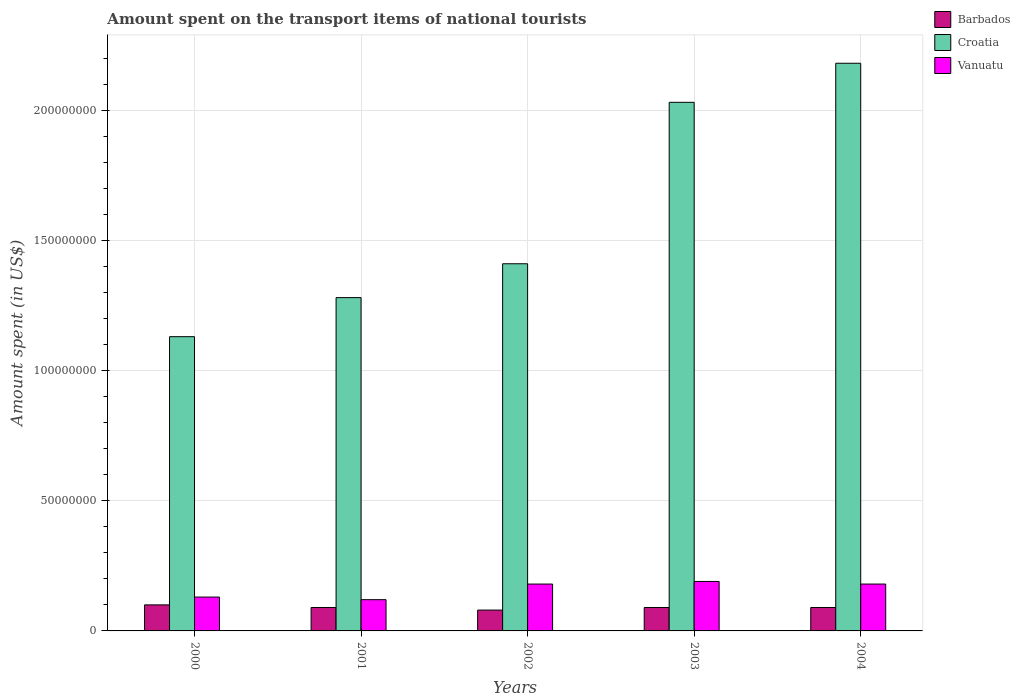How many different coloured bars are there?
Keep it short and to the point. 3. How many groups of bars are there?
Your answer should be compact. 5. Are the number of bars on each tick of the X-axis equal?
Your answer should be very brief. Yes. How many bars are there on the 4th tick from the left?
Provide a short and direct response. 3. What is the label of the 1st group of bars from the left?
Provide a short and direct response. 2000. In how many cases, is the number of bars for a given year not equal to the number of legend labels?
Give a very brief answer. 0. What is the amount spent on the transport items of national tourists in Barbados in 2000?
Provide a succinct answer. 1.00e+07. Across all years, what is the minimum amount spent on the transport items of national tourists in Vanuatu?
Make the answer very short. 1.20e+07. What is the total amount spent on the transport items of national tourists in Vanuatu in the graph?
Offer a terse response. 8.00e+07. What is the difference between the amount spent on the transport items of national tourists in Vanuatu in 2000 and that in 2002?
Offer a terse response. -5.00e+06. What is the difference between the amount spent on the transport items of national tourists in Vanuatu in 2000 and the amount spent on the transport items of national tourists in Croatia in 2001?
Your response must be concise. -1.15e+08. What is the average amount spent on the transport items of national tourists in Vanuatu per year?
Make the answer very short. 1.60e+07. In the year 2000, what is the difference between the amount spent on the transport items of national tourists in Vanuatu and amount spent on the transport items of national tourists in Croatia?
Ensure brevity in your answer.  -1.00e+08. In how many years, is the amount spent on the transport items of national tourists in Vanuatu greater than 140000000 US$?
Your answer should be very brief. 0. What is the ratio of the amount spent on the transport items of national tourists in Vanuatu in 2000 to that in 2001?
Offer a very short reply. 1.08. Is the amount spent on the transport items of national tourists in Croatia in 2003 less than that in 2004?
Keep it short and to the point. Yes. Is the difference between the amount spent on the transport items of national tourists in Vanuatu in 2001 and 2004 greater than the difference between the amount spent on the transport items of national tourists in Croatia in 2001 and 2004?
Offer a very short reply. Yes. In how many years, is the amount spent on the transport items of national tourists in Croatia greater than the average amount spent on the transport items of national tourists in Croatia taken over all years?
Your answer should be compact. 2. What does the 3rd bar from the left in 2004 represents?
Offer a terse response. Vanuatu. What does the 2nd bar from the right in 2000 represents?
Ensure brevity in your answer.  Croatia. Is it the case that in every year, the sum of the amount spent on the transport items of national tourists in Barbados and amount spent on the transport items of national tourists in Vanuatu is greater than the amount spent on the transport items of national tourists in Croatia?
Keep it short and to the point. No. How many years are there in the graph?
Keep it short and to the point. 5. Are the values on the major ticks of Y-axis written in scientific E-notation?
Provide a short and direct response. No. Does the graph contain any zero values?
Your response must be concise. No. Where does the legend appear in the graph?
Provide a succinct answer. Top right. What is the title of the graph?
Make the answer very short. Amount spent on the transport items of national tourists. Does "Namibia" appear as one of the legend labels in the graph?
Keep it short and to the point. No. What is the label or title of the Y-axis?
Ensure brevity in your answer.  Amount spent (in US$). What is the Amount spent (in US$) of Barbados in 2000?
Your response must be concise. 1.00e+07. What is the Amount spent (in US$) in Croatia in 2000?
Your answer should be compact. 1.13e+08. What is the Amount spent (in US$) in Vanuatu in 2000?
Give a very brief answer. 1.30e+07. What is the Amount spent (in US$) in Barbados in 2001?
Make the answer very short. 9.00e+06. What is the Amount spent (in US$) of Croatia in 2001?
Offer a terse response. 1.28e+08. What is the Amount spent (in US$) in Barbados in 2002?
Offer a terse response. 8.00e+06. What is the Amount spent (in US$) of Croatia in 2002?
Ensure brevity in your answer.  1.41e+08. What is the Amount spent (in US$) of Vanuatu in 2002?
Your answer should be compact. 1.80e+07. What is the Amount spent (in US$) of Barbados in 2003?
Provide a short and direct response. 9.00e+06. What is the Amount spent (in US$) in Croatia in 2003?
Your response must be concise. 2.03e+08. What is the Amount spent (in US$) in Vanuatu in 2003?
Offer a very short reply. 1.90e+07. What is the Amount spent (in US$) in Barbados in 2004?
Offer a terse response. 9.00e+06. What is the Amount spent (in US$) of Croatia in 2004?
Offer a terse response. 2.18e+08. What is the Amount spent (in US$) of Vanuatu in 2004?
Offer a terse response. 1.80e+07. Across all years, what is the maximum Amount spent (in US$) in Barbados?
Provide a succinct answer. 1.00e+07. Across all years, what is the maximum Amount spent (in US$) of Croatia?
Make the answer very short. 2.18e+08. Across all years, what is the maximum Amount spent (in US$) in Vanuatu?
Provide a short and direct response. 1.90e+07. Across all years, what is the minimum Amount spent (in US$) of Croatia?
Offer a very short reply. 1.13e+08. Across all years, what is the minimum Amount spent (in US$) of Vanuatu?
Give a very brief answer. 1.20e+07. What is the total Amount spent (in US$) of Barbados in the graph?
Provide a short and direct response. 4.50e+07. What is the total Amount spent (in US$) in Croatia in the graph?
Your answer should be compact. 8.03e+08. What is the total Amount spent (in US$) in Vanuatu in the graph?
Make the answer very short. 8.00e+07. What is the difference between the Amount spent (in US$) of Barbados in 2000 and that in 2001?
Offer a very short reply. 1.00e+06. What is the difference between the Amount spent (in US$) of Croatia in 2000 and that in 2001?
Give a very brief answer. -1.50e+07. What is the difference between the Amount spent (in US$) of Barbados in 2000 and that in 2002?
Offer a very short reply. 2.00e+06. What is the difference between the Amount spent (in US$) in Croatia in 2000 and that in 2002?
Give a very brief answer. -2.80e+07. What is the difference between the Amount spent (in US$) of Vanuatu in 2000 and that in 2002?
Offer a very short reply. -5.00e+06. What is the difference between the Amount spent (in US$) in Croatia in 2000 and that in 2003?
Your answer should be very brief. -9.00e+07. What is the difference between the Amount spent (in US$) of Vanuatu in 2000 and that in 2003?
Give a very brief answer. -6.00e+06. What is the difference between the Amount spent (in US$) of Croatia in 2000 and that in 2004?
Your answer should be very brief. -1.05e+08. What is the difference between the Amount spent (in US$) in Vanuatu in 2000 and that in 2004?
Your answer should be very brief. -5.00e+06. What is the difference between the Amount spent (in US$) of Barbados in 2001 and that in 2002?
Provide a short and direct response. 1.00e+06. What is the difference between the Amount spent (in US$) in Croatia in 2001 and that in 2002?
Your answer should be very brief. -1.30e+07. What is the difference between the Amount spent (in US$) of Vanuatu in 2001 and that in 2002?
Your answer should be very brief. -6.00e+06. What is the difference between the Amount spent (in US$) in Croatia in 2001 and that in 2003?
Give a very brief answer. -7.50e+07. What is the difference between the Amount spent (in US$) in Vanuatu in 2001 and that in 2003?
Your answer should be very brief. -7.00e+06. What is the difference between the Amount spent (in US$) of Barbados in 2001 and that in 2004?
Your answer should be very brief. 0. What is the difference between the Amount spent (in US$) of Croatia in 2001 and that in 2004?
Provide a short and direct response. -9.00e+07. What is the difference between the Amount spent (in US$) in Vanuatu in 2001 and that in 2004?
Offer a terse response. -6.00e+06. What is the difference between the Amount spent (in US$) of Barbados in 2002 and that in 2003?
Give a very brief answer. -1.00e+06. What is the difference between the Amount spent (in US$) in Croatia in 2002 and that in 2003?
Your response must be concise. -6.20e+07. What is the difference between the Amount spent (in US$) in Barbados in 2002 and that in 2004?
Offer a terse response. -1.00e+06. What is the difference between the Amount spent (in US$) of Croatia in 2002 and that in 2004?
Keep it short and to the point. -7.70e+07. What is the difference between the Amount spent (in US$) in Vanuatu in 2002 and that in 2004?
Provide a succinct answer. 0. What is the difference between the Amount spent (in US$) of Croatia in 2003 and that in 2004?
Your answer should be compact. -1.50e+07. What is the difference between the Amount spent (in US$) of Vanuatu in 2003 and that in 2004?
Give a very brief answer. 1.00e+06. What is the difference between the Amount spent (in US$) in Barbados in 2000 and the Amount spent (in US$) in Croatia in 2001?
Provide a short and direct response. -1.18e+08. What is the difference between the Amount spent (in US$) in Barbados in 2000 and the Amount spent (in US$) in Vanuatu in 2001?
Make the answer very short. -2.00e+06. What is the difference between the Amount spent (in US$) of Croatia in 2000 and the Amount spent (in US$) of Vanuatu in 2001?
Your response must be concise. 1.01e+08. What is the difference between the Amount spent (in US$) in Barbados in 2000 and the Amount spent (in US$) in Croatia in 2002?
Provide a succinct answer. -1.31e+08. What is the difference between the Amount spent (in US$) of Barbados in 2000 and the Amount spent (in US$) of Vanuatu in 2002?
Provide a succinct answer. -8.00e+06. What is the difference between the Amount spent (in US$) of Croatia in 2000 and the Amount spent (in US$) of Vanuatu in 2002?
Offer a very short reply. 9.50e+07. What is the difference between the Amount spent (in US$) of Barbados in 2000 and the Amount spent (in US$) of Croatia in 2003?
Keep it short and to the point. -1.93e+08. What is the difference between the Amount spent (in US$) of Barbados in 2000 and the Amount spent (in US$) of Vanuatu in 2003?
Your response must be concise. -9.00e+06. What is the difference between the Amount spent (in US$) in Croatia in 2000 and the Amount spent (in US$) in Vanuatu in 2003?
Provide a succinct answer. 9.40e+07. What is the difference between the Amount spent (in US$) of Barbados in 2000 and the Amount spent (in US$) of Croatia in 2004?
Your answer should be very brief. -2.08e+08. What is the difference between the Amount spent (in US$) of Barbados in 2000 and the Amount spent (in US$) of Vanuatu in 2004?
Provide a short and direct response. -8.00e+06. What is the difference between the Amount spent (in US$) of Croatia in 2000 and the Amount spent (in US$) of Vanuatu in 2004?
Your response must be concise. 9.50e+07. What is the difference between the Amount spent (in US$) of Barbados in 2001 and the Amount spent (in US$) of Croatia in 2002?
Offer a terse response. -1.32e+08. What is the difference between the Amount spent (in US$) in Barbados in 2001 and the Amount spent (in US$) in Vanuatu in 2002?
Your response must be concise. -9.00e+06. What is the difference between the Amount spent (in US$) of Croatia in 2001 and the Amount spent (in US$) of Vanuatu in 2002?
Keep it short and to the point. 1.10e+08. What is the difference between the Amount spent (in US$) of Barbados in 2001 and the Amount spent (in US$) of Croatia in 2003?
Ensure brevity in your answer.  -1.94e+08. What is the difference between the Amount spent (in US$) in Barbados in 2001 and the Amount spent (in US$) in Vanuatu in 2003?
Your response must be concise. -1.00e+07. What is the difference between the Amount spent (in US$) in Croatia in 2001 and the Amount spent (in US$) in Vanuatu in 2003?
Your answer should be compact. 1.09e+08. What is the difference between the Amount spent (in US$) of Barbados in 2001 and the Amount spent (in US$) of Croatia in 2004?
Your answer should be compact. -2.09e+08. What is the difference between the Amount spent (in US$) in Barbados in 2001 and the Amount spent (in US$) in Vanuatu in 2004?
Your answer should be very brief. -9.00e+06. What is the difference between the Amount spent (in US$) in Croatia in 2001 and the Amount spent (in US$) in Vanuatu in 2004?
Offer a very short reply. 1.10e+08. What is the difference between the Amount spent (in US$) in Barbados in 2002 and the Amount spent (in US$) in Croatia in 2003?
Ensure brevity in your answer.  -1.95e+08. What is the difference between the Amount spent (in US$) of Barbados in 2002 and the Amount spent (in US$) of Vanuatu in 2003?
Ensure brevity in your answer.  -1.10e+07. What is the difference between the Amount spent (in US$) of Croatia in 2002 and the Amount spent (in US$) of Vanuatu in 2003?
Provide a succinct answer. 1.22e+08. What is the difference between the Amount spent (in US$) in Barbados in 2002 and the Amount spent (in US$) in Croatia in 2004?
Your response must be concise. -2.10e+08. What is the difference between the Amount spent (in US$) in Barbados in 2002 and the Amount spent (in US$) in Vanuatu in 2004?
Keep it short and to the point. -1.00e+07. What is the difference between the Amount spent (in US$) in Croatia in 2002 and the Amount spent (in US$) in Vanuatu in 2004?
Make the answer very short. 1.23e+08. What is the difference between the Amount spent (in US$) in Barbados in 2003 and the Amount spent (in US$) in Croatia in 2004?
Offer a terse response. -2.09e+08. What is the difference between the Amount spent (in US$) in Barbados in 2003 and the Amount spent (in US$) in Vanuatu in 2004?
Your response must be concise. -9.00e+06. What is the difference between the Amount spent (in US$) in Croatia in 2003 and the Amount spent (in US$) in Vanuatu in 2004?
Provide a short and direct response. 1.85e+08. What is the average Amount spent (in US$) in Barbados per year?
Provide a short and direct response. 9.00e+06. What is the average Amount spent (in US$) in Croatia per year?
Your response must be concise. 1.61e+08. What is the average Amount spent (in US$) in Vanuatu per year?
Make the answer very short. 1.60e+07. In the year 2000, what is the difference between the Amount spent (in US$) in Barbados and Amount spent (in US$) in Croatia?
Give a very brief answer. -1.03e+08. In the year 2000, what is the difference between the Amount spent (in US$) in Barbados and Amount spent (in US$) in Vanuatu?
Offer a terse response. -3.00e+06. In the year 2001, what is the difference between the Amount spent (in US$) in Barbados and Amount spent (in US$) in Croatia?
Your response must be concise. -1.19e+08. In the year 2001, what is the difference between the Amount spent (in US$) of Croatia and Amount spent (in US$) of Vanuatu?
Your response must be concise. 1.16e+08. In the year 2002, what is the difference between the Amount spent (in US$) of Barbados and Amount spent (in US$) of Croatia?
Offer a terse response. -1.33e+08. In the year 2002, what is the difference between the Amount spent (in US$) of Barbados and Amount spent (in US$) of Vanuatu?
Make the answer very short. -1.00e+07. In the year 2002, what is the difference between the Amount spent (in US$) in Croatia and Amount spent (in US$) in Vanuatu?
Offer a very short reply. 1.23e+08. In the year 2003, what is the difference between the Amount spent (in US$) in Barbados and Amount spent (in US$) in Croatia?
Make the answer very short. -1.94e+08. In the year 2003, what is the difference between the Amount spent (in US$) of Barbados and Amount spent (in US$) of Vanuatu?
Provide a short and direct response. -1.00e+07. In the year 2003, what is the difference between the Amount spent (in US$) in Croatia and Amount spent (in US$) in Vanuatu?
Provide a short and direct response. 1.84e+08. In the year 2004, what is the difference between the Amount spent (in US$) of Barbados and Amount spent (in US$) of Croatia?
Your answer should be compact. -2.09e+08. In the year 2004, what is the difference between the Amount spent (in US$) of Barbados and Amount spent (in US$) of Vanuatu?
Offer a very short reply. -9.00e+06. What is the ratio of the Amount spent (in US$) in Croatia in 2000 to that in 2001?
Your answer should be compact. 0.88. What is the ratio of the Amount spent (in US$) of Barbados in 2000 to that in 2002?
Offer a very short reply. 1.25. What is the ratio of the Amount spent (in US$) in Croatia in 2000 to that in 2002?
Your response must be concise. 0.8. What is the ratio of the Amount spent (in US$) in Vanuatu in 2000 to that in 2002?
Keep it short and to the point. 0.72. What is the ratio of the Amount spent (in US$) of Barbados in 2000 to that in 2003?
Provide a succinct answer. 1.11. What is the ratio of the Amount spent (in US$) of Croatia in 2000 to that in 2003?
Make the answer very short. 0.56. What is the ratio of the Amount spent (in US$) of Vanuatu in 2000 to that in 2003?
Provide a succinct answer. 0.68. What is the ratio of the Amount spent (in US$) in Barbados in 2000 to that in 2004?
Your response must be concise. 1.11. What is the ratio of the Amount spent (in US$) of Croatia in 2000 to that in 2004?
Offer a terse response. 0.52. What is the ratio of the Amount spent (in US$) of Vanuatu in 2000 to that in 2004?
Keep it short and to the point. 0.72. What is the ratio of the Amount spent (in US$) of Barbados in 2001 to that in 2002?
Give a very brief answer. 1.12. What is the ratio of the Amount spent (in US$) of Croatia in 2001 to that in 2002?
Offer a terse response. 0.91. What is the ratio of the Amount spent (in US$) in Vanuatu in 2001 to that in 2002?
Provide a succinct answer. 0.67. What is the ratio of the Amount spent (in US$) in Barbados in 2001 to that in 2003?
Ensure brevity in your answer.  1. What is the ratio of the Amount spent (in US$) of Croatia in 2001 to that in 2003?
Make the answer very short. 0.63. What is the ratio of the Amount spent (in US$) in Vanuatu in 2001 to that in 2003?
Provide a succinct answer. 0.63. What is the ratio of the Amount spent (in US$) of Croatia in 2001 to that in 2004?
Make the answer very short. 0.59. What is the ratio of the Amount spent (in US$) in Vanuatu in 2001 to that in 2004?
Your answer should be very brief. 0.67. What is the ratio of the Amount spent (in US$) in Croatia in 2002 to that in 2003?
Make the answer very short. 0.69. What is the ratio of the Amount spent (in US$) of Vanuatu in 2002 to that in 2003?
Your response must be concise. 0.95. What is the ratio of the Amount spent (in US$) of Croatia in 2002 to that in 2004?
Provide a succinct answer. 0.65. What is the ratio of the Amount spent (in US$) in Barbados in 2003 to that in 2004?
Provide a succinct answer. 1. What is the ratio of the Amount spent (in US$) of Croatia in 2003 to that in 2004?
Offer a very short reply. 0.93. What is the ratio of the Amount spent (in US$) in Vanuatu in 2003 to that in 2004?
Provide a succinct answer. 1.06. What is the difference between the highest and the second highest Amount spent (in US$) of Barbados?
Keep it short and to the point. 1.00e+06. What is the difference between the highest and the second highest Amount spent (in US$) of Croatia?
Your answer should be compact. 1.50e+07. What is the difference between the highest and the second highest Amount spent (in US$) of Vanuatu?
Make the answer very short. 1.00e+06. What is the difference between the highest and the lowest Amount spent (in US$) in Croatia?
Provide a short and direct response. 1.05e+08. 